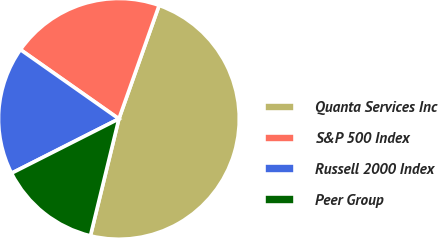Convert chart to OTSL. <chart><loc_0><loc_0><loc_500><loc_500><pie_chart><fcel>Quanta Services Inc<fcel>S&P 500 Index<fcel>Russell 2000 Index<fcel>Peer Group<nl><fcel>48.38%<fcel>20.67%<fcel>17.21%<fcel>13.74%<nl></chart> 